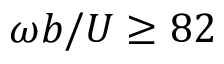<formula> <loc_0><loc_0><loc_500><loc_500>\omega b / U \geq 8 2</formula> 